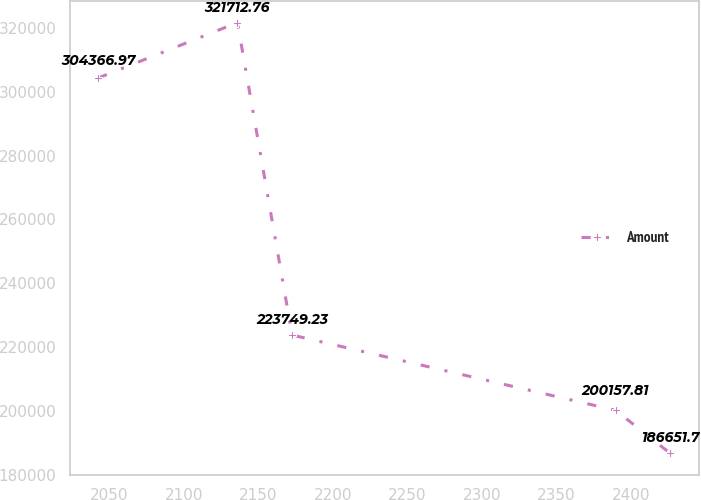Convert chart. <chart><loc_0><loc_0><loc_500><loc_500><line_chart><ecel><fcel>Amount<nl><fcel>2042.73<fcel>304367<nl><fcel>2136.06<fcel>321713<nl><fcel>2172.73<fcel>223749<nl><fcel>2389.71<fcel>200158<nl><fcel>2426.38<fcel>186652<nl></chart> 